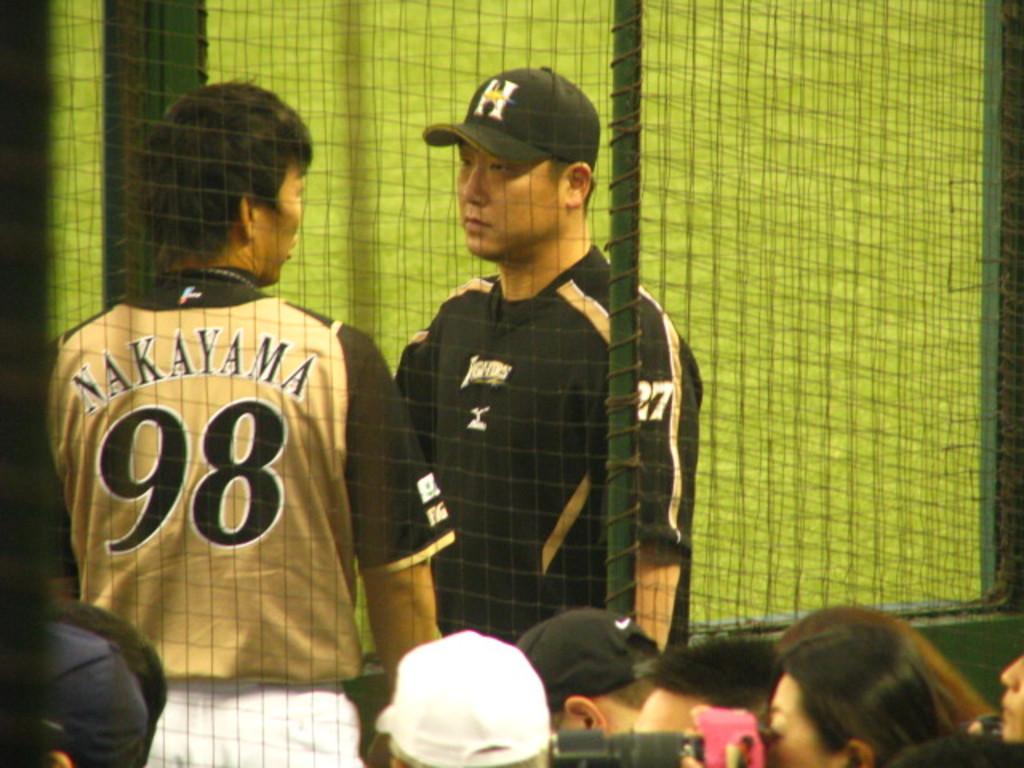What's the name of the player with his back to the player?
Make the answer very short. Nakayama. 